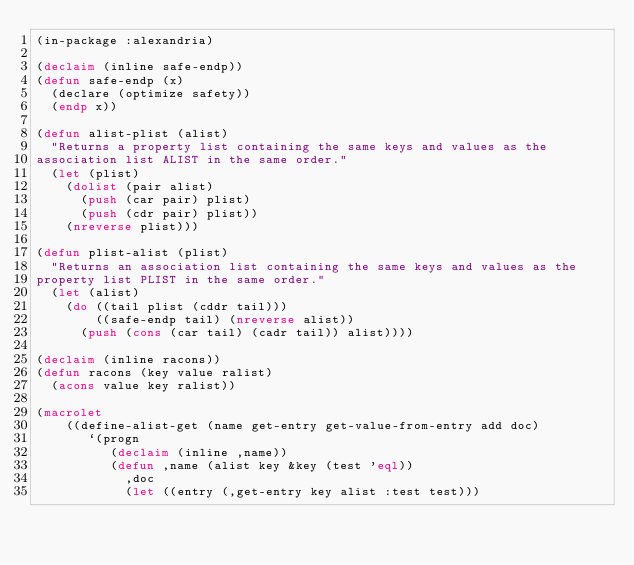Convert code to text. <code><loc_0><loc_0><loc_500><loc_500><_Lisp_>(in-package :alexandria)

(declaim (inline safe-endp))
(defun safe-endp (x)
  (declare (optimize safety))
  (endp x))

(defun alist-plist (alist)
  "Returns a property list containing the same keys and values as the
association list ALIST in the same order."
  (let (plist)
    (dolist (pair alist)
      (push (car pair) plist)
      (push (cdr pair) plist))
    (nreverse plist)))

(defun plist-alist (plist)
  "Returns an association list containing the same keys and values as the
property list PLIST in the same order."
  (let (alist)
    (do ((tail plist (cddr tail)))
        ((safe-endp tail) (nreverse alist))
      (push (cons (car tail) (cadr tail)) alist))))

(declaim (inline racons))
(defun racons (key value ralist)
  (acons value key ralist))

(macrolet
    ((define-alist-get (name get-entry get-value-from-entry add doc)
       `(progn
          (declaim (inline ,name))
          (defun ,name (alist key &key (test 'eql))
            ,doc
            (let ((entry (,get-entry key alist :test test)))</code> 